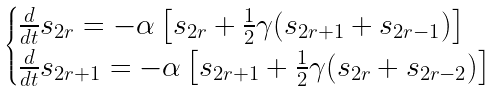Convert formula to latex. <formula><loc_0><loc_0><loc_500><loc_500>\begin{cases} \frac { d } { d t } s _ { 2 r } = - \alpha \left [ s _ { 2 r } + \frac { 1 } { 2 } \gamma ( s _ { 2 r + 1 } + s _ { 2 r - 1 } ) \right ] \\ \frac { d } { d t } s _ { 2 r + 1 } = - \alpha \left [ s _ { 2 r + 1 } + \frac { 1 } { 2 } \gamma ( s _ { 2 r } + s _ { 2 r - 2 } ) \right ] \end{cases}</formula> 